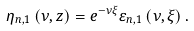Convert formula to latex. <formula><loc_0><loc_0><loc_500><loc_500>\eta _ { n , 1 } \left ( { \nu , z } \right ) = e ^ { - \nu \xi } \varepsilon _ { n , 1 } \left ( { \nu , \xi } \right ) .</formula> 